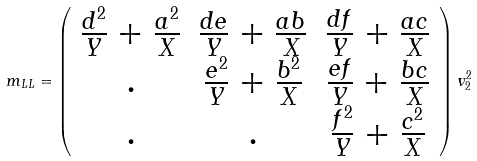Convert formula to latex. <formula><loc_0><loc_0><loc_500><loc_500>m _ { L L } = \left ( \begin{array} { c c c } { \frac { d ^ { 2 } } { Y } } + \frac { a ^ { 2 } } { X } & { \frac { d e } { Y } } + \frac { a b } { X } & { \frac { d f } { Y } } + \frac { a c } { X } \\ . & { \frac { e ^ { 2 } } { Y } } + \frac { b ^ { 2 } } { X } & { \frac { e f } { Y } } + \frac { b c } { X } \\ . & . & { \frac { f ^ { 2 } } { Y } } + \frac { c ^ { 2 } } { X } \end{array} \right ) { v _ { 2 } ^ { 2 } }</formula> 